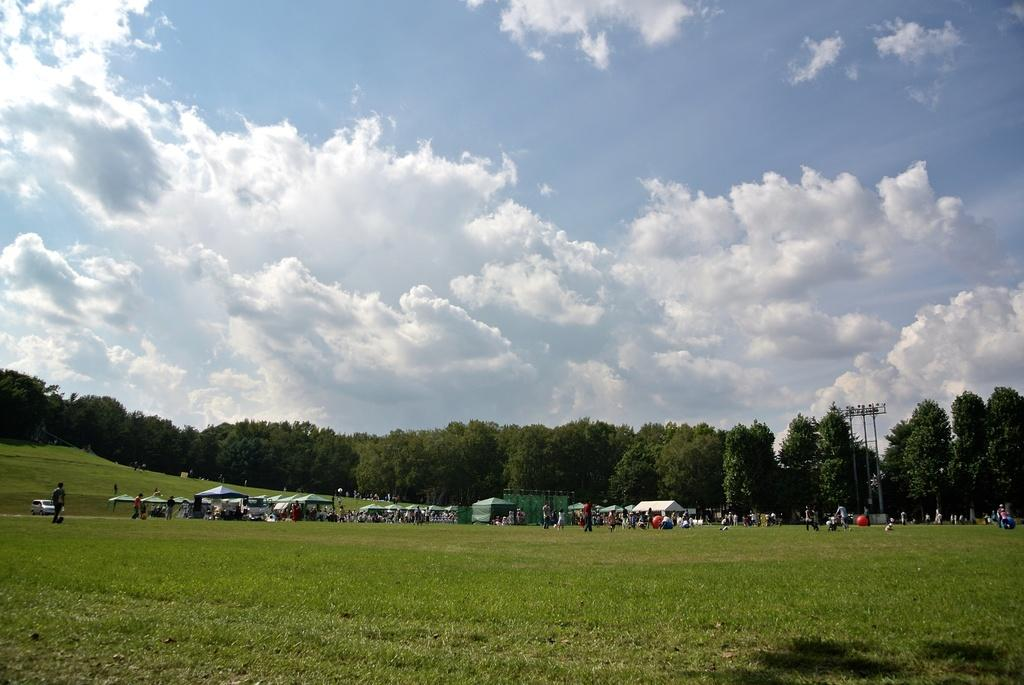How many people are in the group visible in the image? There is a group of people in the image, but the exact number cannot be determined from the provided facts. What objects are present in the image besides the people? There are balls, tents, vehicles, poles on the ground, grass, a group of trees, and the sky visible in the image. What type of terrain is visible in the image? The grass and group of trees suggest that the terrain is outdoors and possibly a grassy area or park. What is the condition of the sky in the image? The sky appears to be cloudy in the image. What type of ornament is hanging from the trees in the image? There is no mention of any ornaments hanging from the trees in the image. 